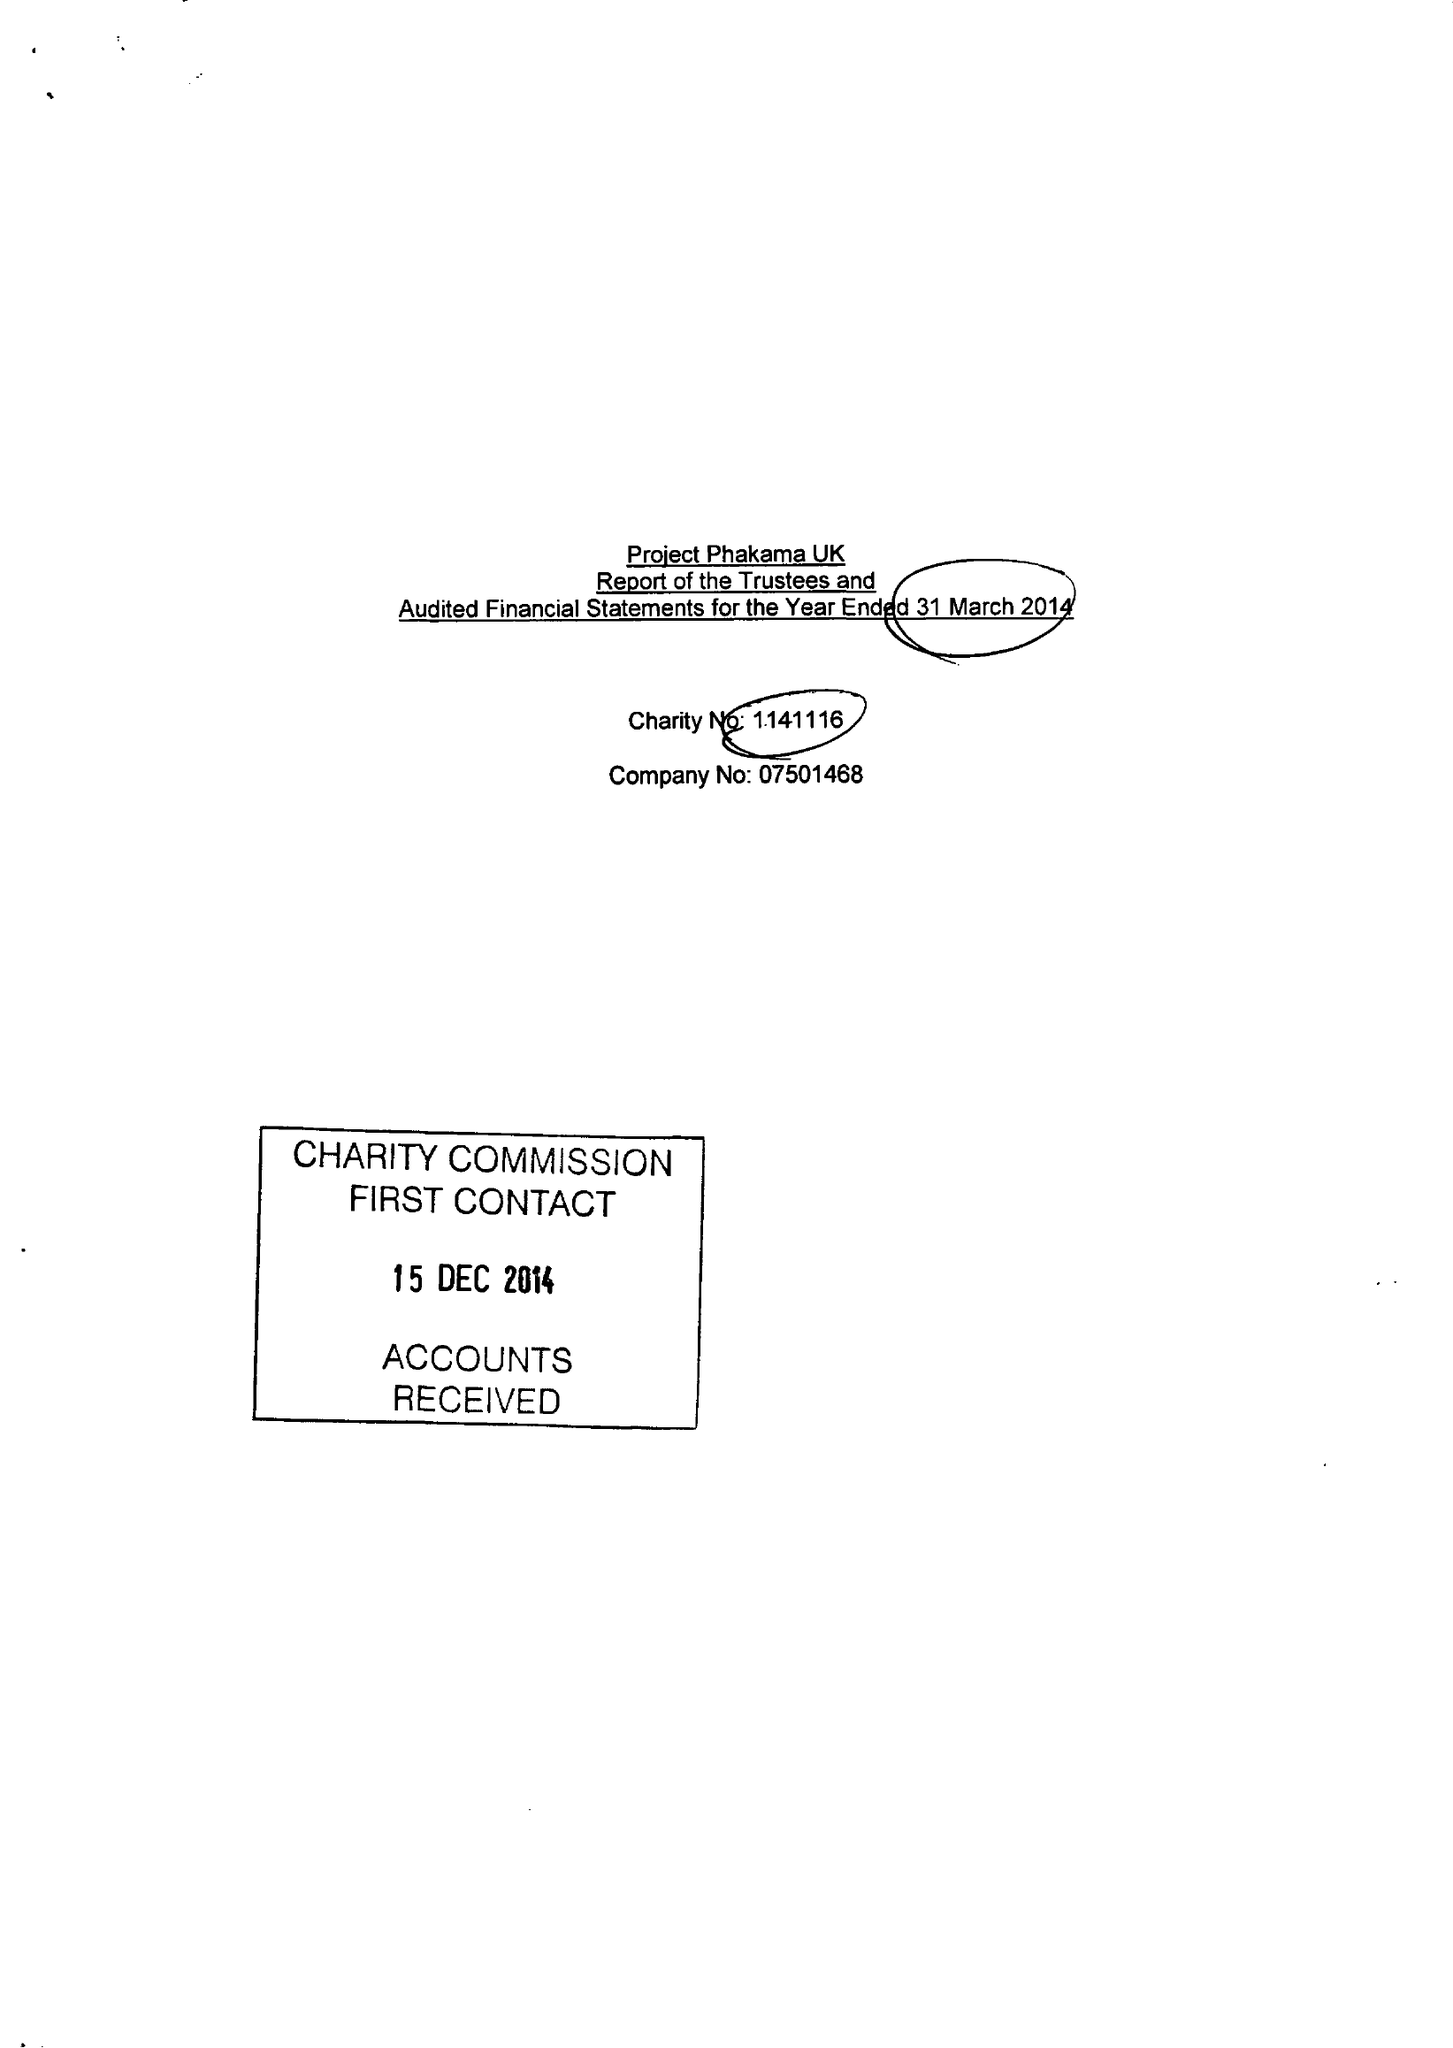What is the value for the charity_number?
Answer the question using a single word or phrase. 1141116 